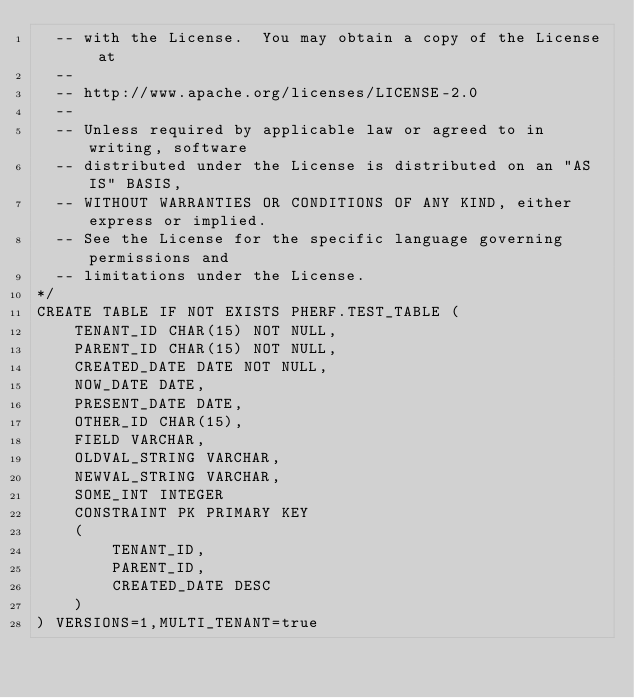Convert code to text. <code><loc_0><loc_0><loc_500><loc_500><_SQL_>  -- with the License.  You may obtain a copy of the License at
  --
  -- http://www.apache.org/licenses/LICENSE-2.0
  --
  -- Unless required by applicable law or agreed to in writing, software
  -- distributed under the License is distributed on an "AS IS" BASIS,
  -- WITHOUT WARRANTIES OR CONDITIONS OF ANY KIND, either express or implied.
  -- See the License for the specific language governing permissions and
  -- limitations under the License.
*/
CREATE TABLE IF NOT EXISTS PHERF.TEST_TABLE (
    TENANT_ID CHAR(15) NOT NULL,
    PARENT_ID CHAR(15) NOT NULL,
    CREATED_DATE DATE NOT NULL,
    NOW_DATE DATE,
    PRESENT_DATE DATE,
    OTHER_ID CHAR(15),
    FIELD VARCHAR,
    OLDVAL_STRING VARCHAR,
    NEWVAL_STRING VARCHAR,
    SOME_INT INTEGER
    CONSTRAINT PK PRIMARY KEY
    (
        TENANT_ID,
        PARENT_ID,
        CREATED_DATE DESC
    )
) VERSIONS=1,MULTI_TENANT=true
</code> 